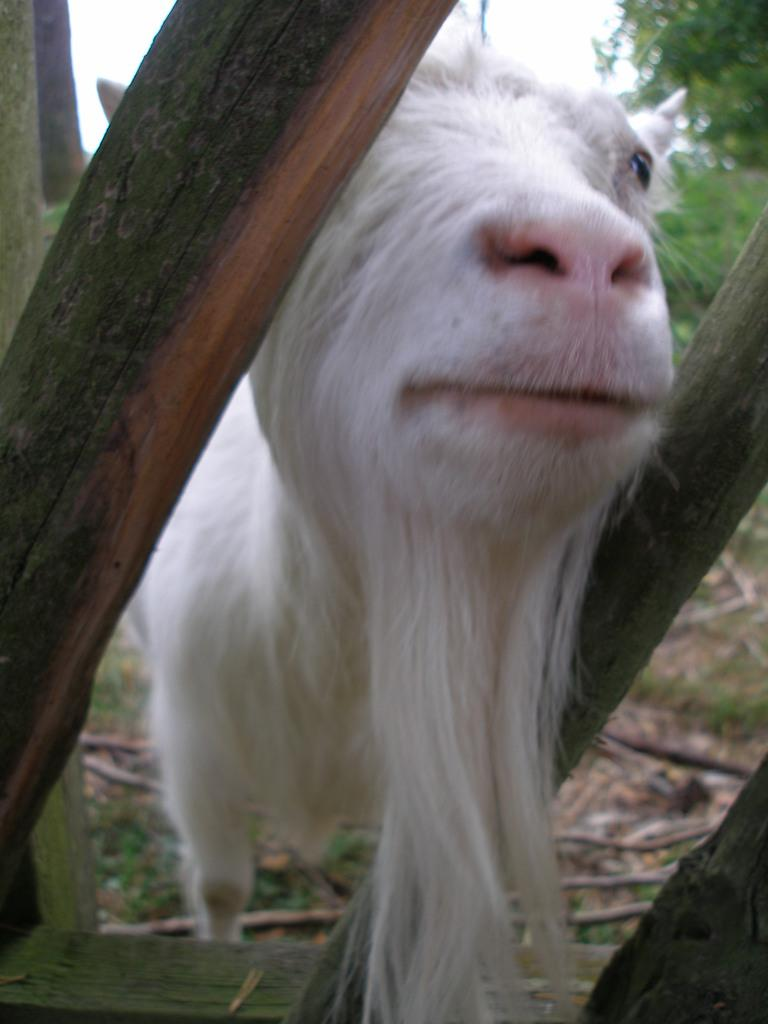What type of animal can be seen in the image? There is an animal in the image, but its specific type is not mentioned in the facts. Where is the animal located in relation to the wooden railing? The animal is standing behind a wooden railing in the image. What type of vegetation is visible in the image? There is a tree visible in the image. What is visible at the top of the image? The sky is visible at the top of the image. What type of ground surface is present at the bottom of the image? There is grass at the bottom of the image. What other objects can be seen in the image? There are sticks in the image. What effect does the wren have on the air in the image? There is no mention of a wren in the image, so it cannot have any effect on the air. 